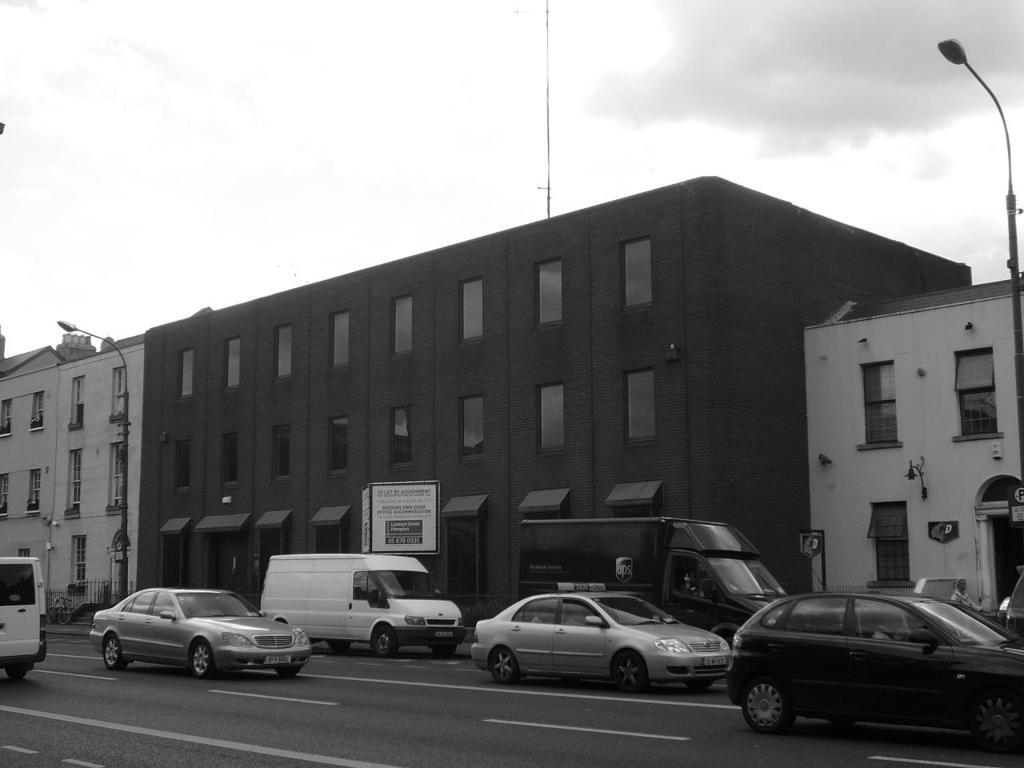What is happening on the road in the image? There are cars moving on the road in the image. What type of buildings can be seen in the image? There are buildings with glass windows visible in the image. What object is located on the right side of the image? There is a street pole on the right side of the image. How does the digestion process work for the street pole in the image? There is no digestion process for the street pole, as it is an inanimate object. What type of bag is being used by the buildings in the image? There are no bags present in the image; it features buildings with glass windows and a street pole. 